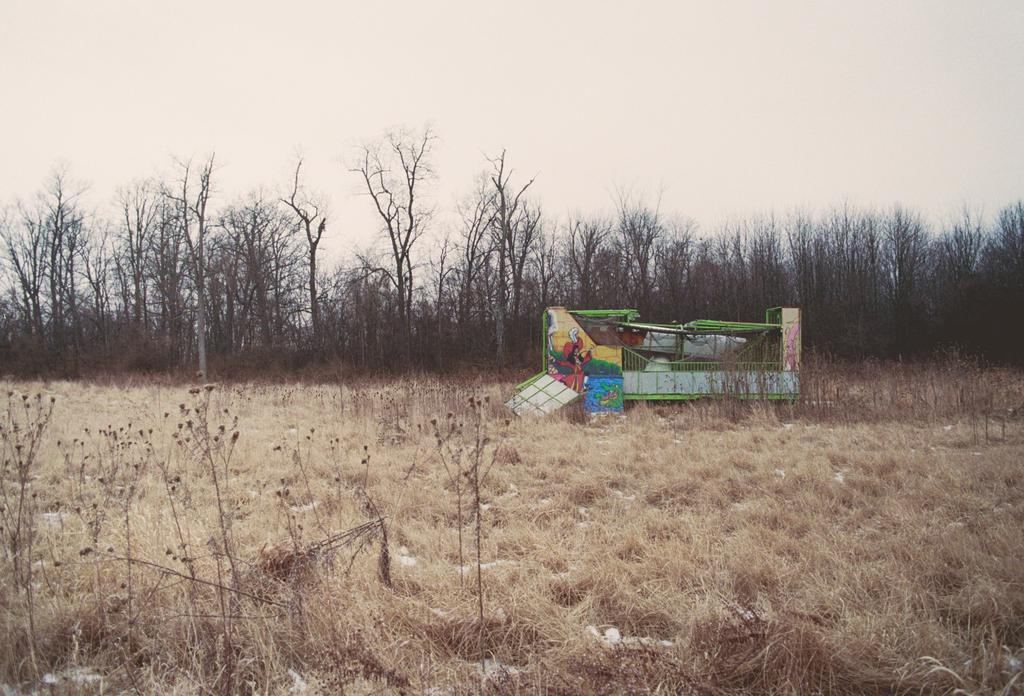What type of vegetation is at the bottom of the image? There is dry grass at the bottom of the image. What can be seen in the background of the image? There are trees in the background of the image. What is visible at the top of the image? The sky is visible at the top of the image. Reasoning: Let' Let's think step by step in order to produce the conversation. We start by identifying the main subjects and objects in the image based on the provided facts. We then formulate questions that focus on the location and characteristics of these subjects and objects, ensuring that each question can be answered definitively with the information given. We avoid yes/no questions and ensure that the language is simple and clear. Absurd Question/Answer: What type of authority figure can be seen on the island in the image? There is no island or authority figure present in the image. What color is the pear in the image? There is no pear present in the image. What type of fruit is hanging from the trees in the image? The provided facts do not mention any specific fruit hanging from the trees, so we cannot definitively answer this question. However, we can say that there are trees in the background of the image. 